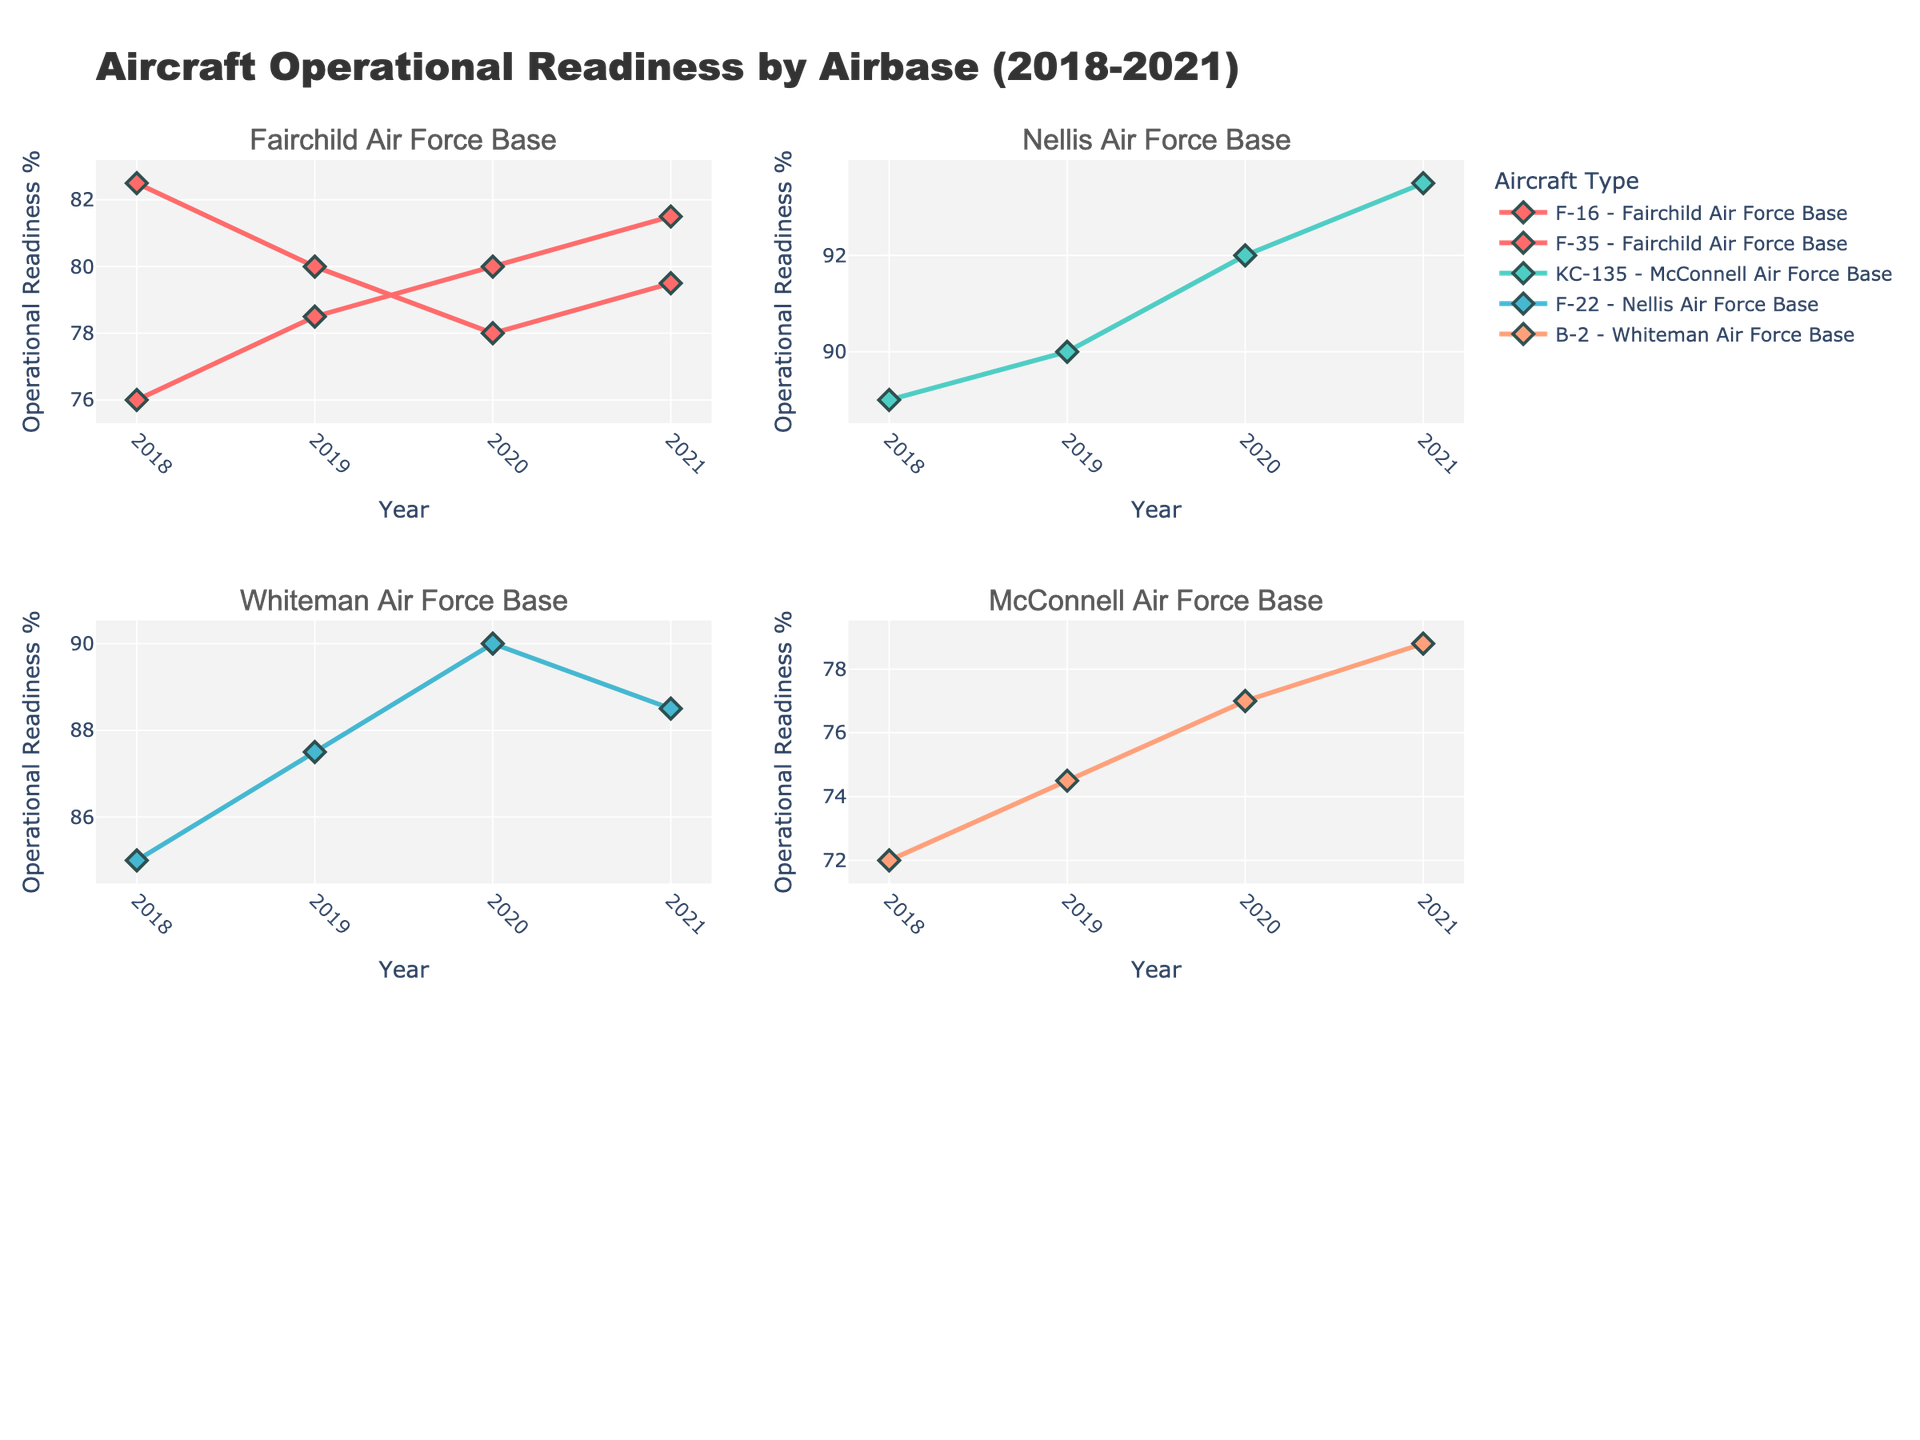What's the title of the plot? The title of the plot is located at the top and describes the overall content of the figure.
Answer: Aircraft Operational Readiness by Airbase (2018-2021) How many airbases are included in the figure? There are subplot titles in the figure, one for each airbase. By counting the unique subplot titles, we can determine the number of airbases.
Answer: 4 Which aircraft type at Nellis Air Force Base had the highest operational readiness percentage in 2020? Locate the subplot for Nellis Air Force Base and identify the markers corresponding to the different aircraft types in the year 2020. The F-22 had the highest operational readiness in 2020.
Answer: F-22 What is the trend of operational readiness for the F-16 at Fairchild Air Force Base from 2018 to 2021? Examine the plot for Fairchild Air Force Base and look at the line for the F-16 from 2018 to 2021. The trend shows a decrease from 2018 to 2020, followed by a slight increase in 2021.
Answer: Decreasing then increasing Which airbase had the highest operational readiness percentage in 2018, and for which aircraft type? Review the 2018 data points across all subplots and identify the highest operational readiness percentage. McConnell Air Force Base had the highest with the KC-135.
Answer: McConnell Air Force Base, KC-135 Compare the operational readiness trajectories of the F-35 at Fairchild Air Force Base and the B-2 at Whiteman Air Force Base from 2018 to 2021. Look at the trends in the respective subplots for the F-35 at Fairchild and the B-2 at Whiteman. Both aircraft types show an increasing trend over time.
Answer: Both increasing What is the difference in operational readiness percentages between 2019 and 2020 for the B-2 at Whiteman Air Force Base? Check the operational readiness percentages for the B-2 at Whiteman in 2019 and 2020, then subtract the 2019 value from the 2020 value. The difference is 77.0 - 74.5 = 2.5%.
Answer: 2.5% How many aircraft types are tracked at Fairchild Air Force Base? Locate the Fairchild Air Force Base subplot and count the distinct aircraft type lines. There are two aircraft types: F-16 and F-35.
Answer: 2 Which airbase showed the most consistent increase in operational readiness from 2018 to 2021? Review all subplots and check for a consistent upward trend in operational readiness over time. McConnell Air Force Base with the KC-135 shows a steadily increasing trend.
Answer: McConnell Air Force Base 